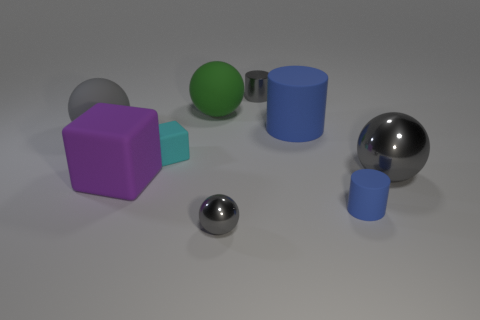Are there an equal number of big purple shiny cylinders and purple rubber cubes?
Your response must be concise. No. There is a small gray object right of the gray metal ball to the left of the big rubber cylinder; what is its shape?
Provide a short and direct response. Cylinder. Do the small rubber thing that is in front of the purple thing and the tiny metallic object to the left of the tiny gray shiny cylinder have the same color?
Offer a terse response. No. Is there any other thing that has the same color as the tiny block?
Make the answer very short. No. The tiny shiny cylinder has what color?
Your answer should be compact. Gray. Are there any yellow metal things?
Ensure brevity in your answer.  No. There is a gray metallic cylinder; are there any cyan matte things to the right of it?
Your answer should be compact. No. There is another tiny thing that is the same shape as the gray matte thing; what is it made of?
Your response must be concise. Metal. Is there any other thing that is made of the same material as the tiny blue object?
Provide a succinct answer. Yes. How many other objects are the same shape as the tiny blue rubber object?
Ensure brevity in your answer.  2. 